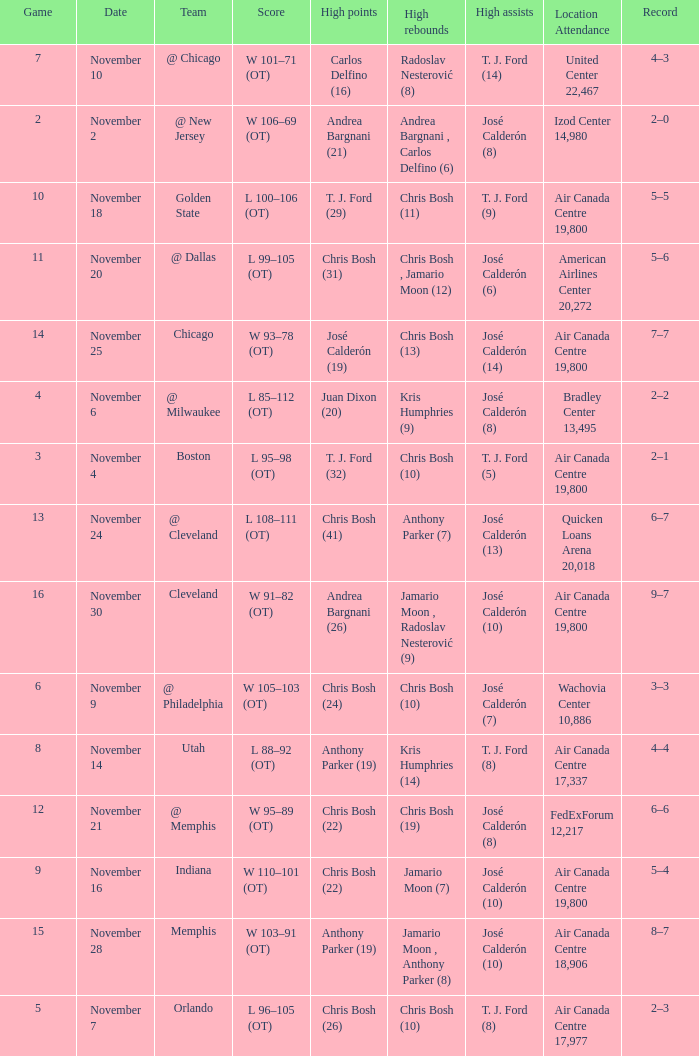Who had the high points when chris bosh (13) had the high rebounds? José Calderón (19). 